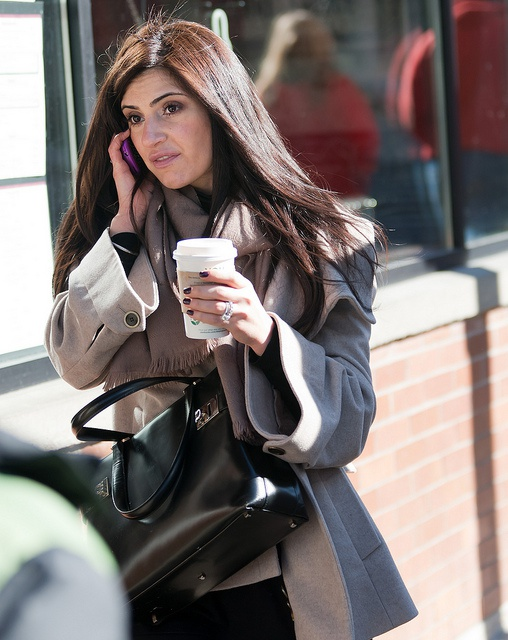Describe the objects in this image and their specific colors. I can see people in beige, black, gray, and lightgray tones, handbag in beige, black, gray, white, and darkgray tones, people in beige, maroon, black, gray, and blue tones, people in beige, maroon, gray, and darkgray tones, and cup in beige, lightgray, darkgray, tan, and gray tones in this image. 